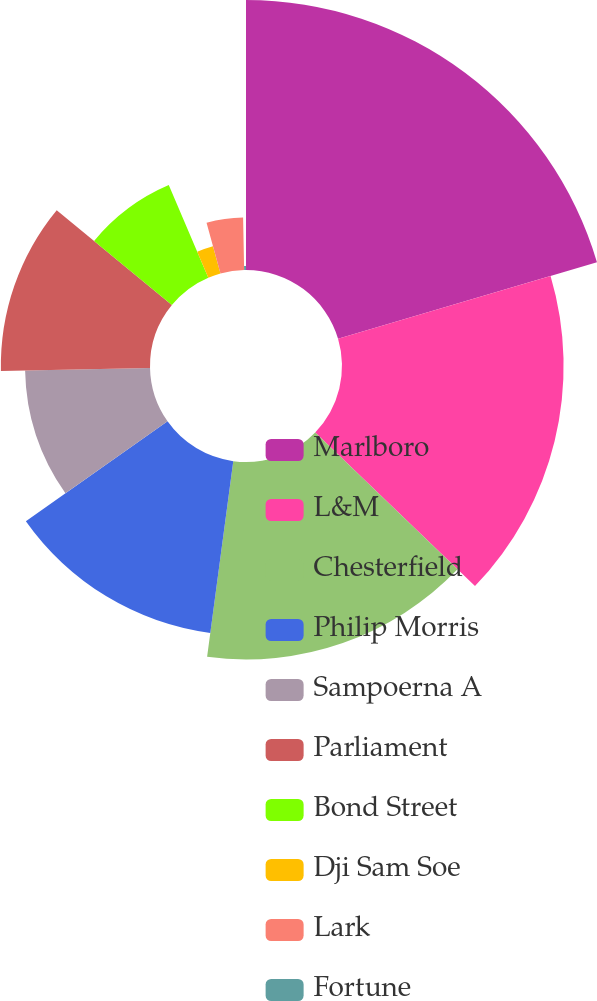<chart> <loc_0><loc_0><loc_500><loc_500><pie_chart><fcel>Marlboro<fcel>L&M<fcel>Chesterfield<fcel>Philip Morris<fcel>Sampoerna A<fcel>Parliament<fcel>Bond Street<fcel>Dji Sam Soe<fcel>Lark<fcel>Fortune<nl><fcel>20.42%<fcel>16.76%<fcel>14.93%<fcel>13.11%<fcel>9.45%<fcel>11.28%<fcel>7.62%<fcel>2.14%<fcel>3.97%<fcel>0.31%<nl></chart> 